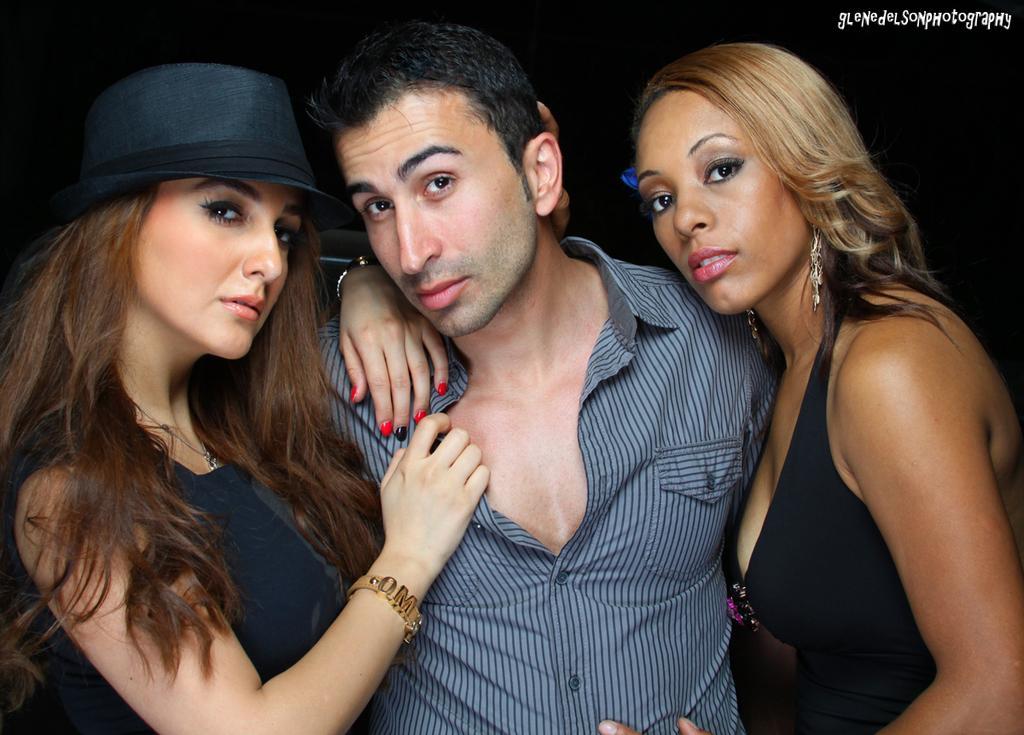How would you summarize this image in a sentence or two? This picture contains three people. The woman on the left corner of the picture wearing black dress who is wearing the black hat is standing beside the man who is wearing the blue color shirt. Beside him, we see women in the black dress is stunning. In the background, it is black in color. 